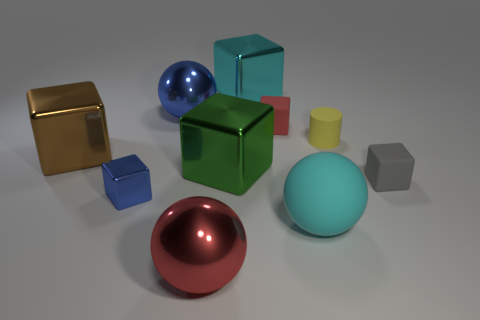There is a big sphere that is behind the tiny block left of the large shiny cube that is behind the big brown shiny cube; what color is it?
Provide a short and direct response. Blue. Are the big cyan thing behind the tiny red matte block and the tiny yellow object made of the same material?
Offer a very short reply. No. How many other objects are the same material as the gray block?
Ensure brevity in your answer.  3. There is a red thing that is the same size as the cyan metal cube; what is it made of?
Offer a very short reply. Metal. Does the big rubber object in front of the cyan shiny block have the same shape as the big cyan object behind the large green cube?
Provide a succinct answer. No. What shape is the green thing that is the same size as the brown metallic cube?
Provide a succinct answer. Cube. Does the large blue thing to the right of the tiny shiny thing have the same material as the large cyan object in front of the gray cube?
Ensure brevity in your answer.  No. Is there a large brown shiny object that is in front of the metallic block that is left of the blue metal block?
Make the answer very short. No. There is a large thing that is made of the same material as the yellow cylinder; what is its color?
Make the answer very short. Cyan. Is the number of yellow matte cubes greater than the number of yellow rubber cylinders?
Provide a succinct answer. No. 